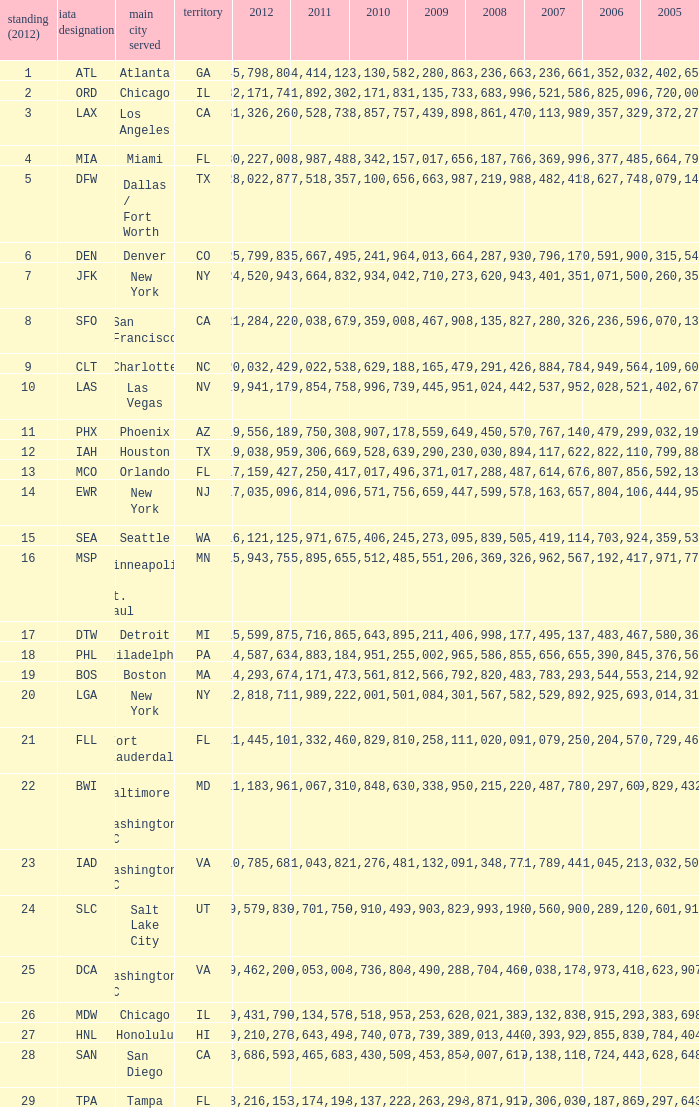When Philadelphia has a 2007 less than 20,796,173 and a 2008 more than 10,215,225, what is the smallest 2009? 15002961.0. 